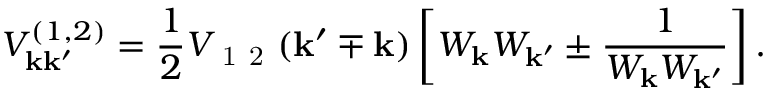Convert formula to latex. <formula><loc_0><loc_0><loc_500><loc_500>V _ { k k ^ { \prime } } ^ { ( 1 , 2 ) } = \frac { 1 } { 2 } V _ { 1 2 } ( k ^ { \prime } \mp k ) \left [ W _ { k } W _ { k ^ { \prime } } \pm \frac { 1 } { W _ { k } W _ { k ^ { \prime } } } \right ] .</formula> 